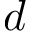<formula> <loc_0><loc_0><loc_500><loc_500>d</formula> 